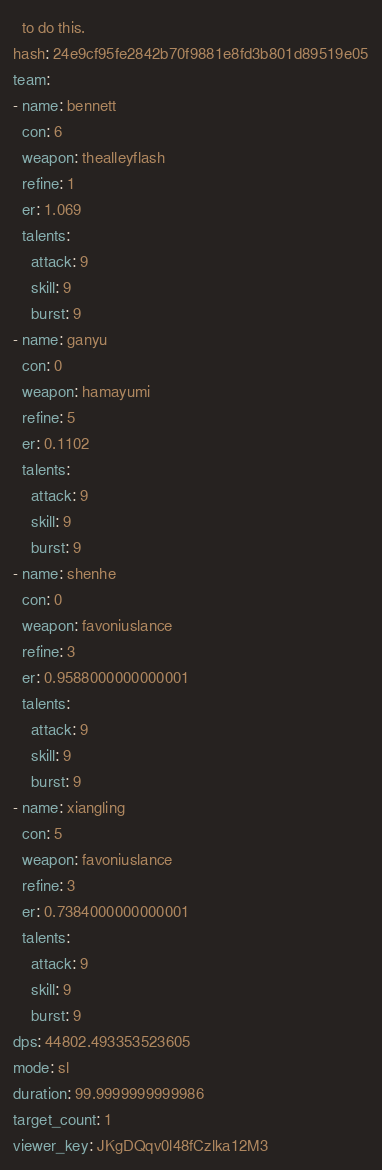Convert code to text. <code><loc_0><loc_0><loc_500><loc_500><_YAML_>  to do this.
hash: 24e9cf95fe2842b70f9881e8fd3b801d89519e05
team:
- name: bennett
  con: 6
  weapon: thealleyflash
  refine: 1
  er: 1.069
  talents:
    attack: 9
    skill: 9
    burst: 9
- name: ganyu
  con: 0
  weapon: hamayumi
  refine: 5
  er: 0.1102
  talents:
    attack: 9
    skill: 9
    burst: 9
- name: shenhe
  con: 0
  weapon: favoniuslance
  refine: 3
  er: 0.9588000000000001
  talents:
    attack: 9
    skill: 9
    burst: 9
- name: xiangling
  con: 5
  weapon: favoniuslance
  refine: 3
  er: 0.7384000000000001
  talents:
    attack: 9
    skill: 9
    burst: 9
dps: 44802.493353523605
mode: sl
duration: 99.9999999999986
target_count: 1
viewer_key: JKgDQqv0l48fCzlka12M3
</code> 